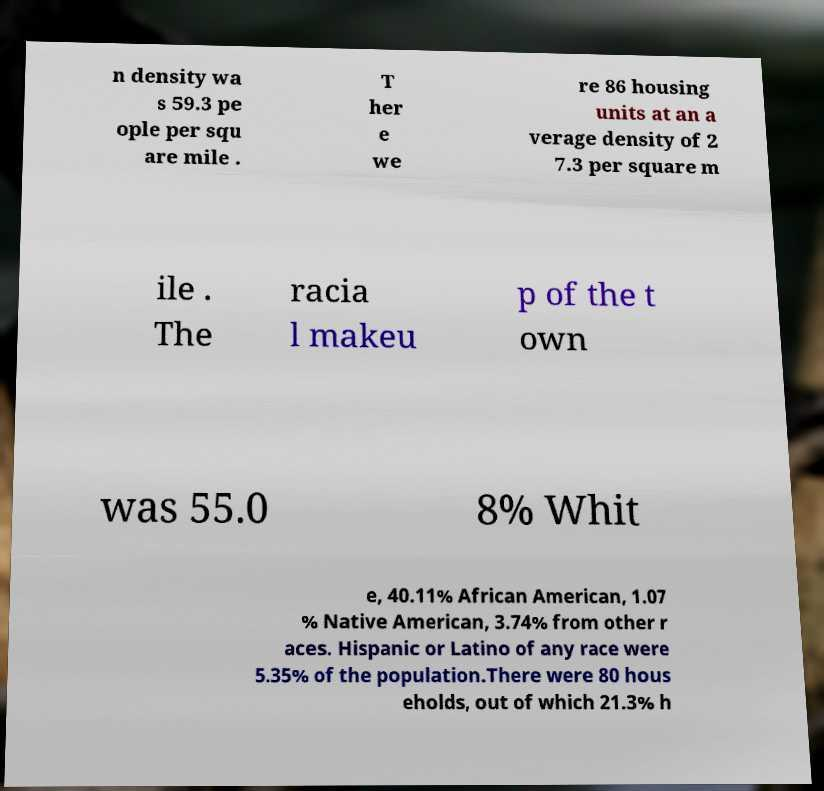I need the written content from this picture converted into text. Can you do that? n density wa s 59.3 pe ople per squ are mile . T her e we re 86 housing units at an a verage density of 2 7.3 per square m ile . The racia l makeu p of the t own was 55.0 8% Whit e, 40.11% African American, 1.07 % Native American, 3.74% from other r aces. Hispanic or Latino of any race were 5.35% of the population.There were 80 hous eholds, out of which 21.3% h 